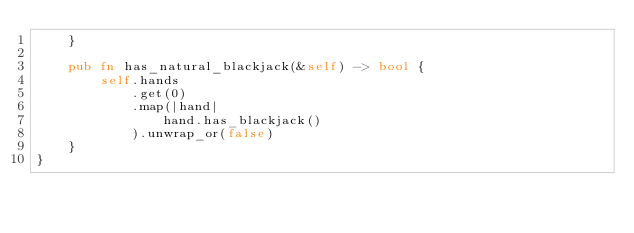<code> <loc_0><loc_0><loc_500><loc_500><_Rust_>    }

    pub fn has_natural_blackjack(&self) -> bool {
        self.hands
            .get(0)
            .map(|hand|
                hand.has_blackjack()
            ).unwrap_or(false)
    }
}</code> 